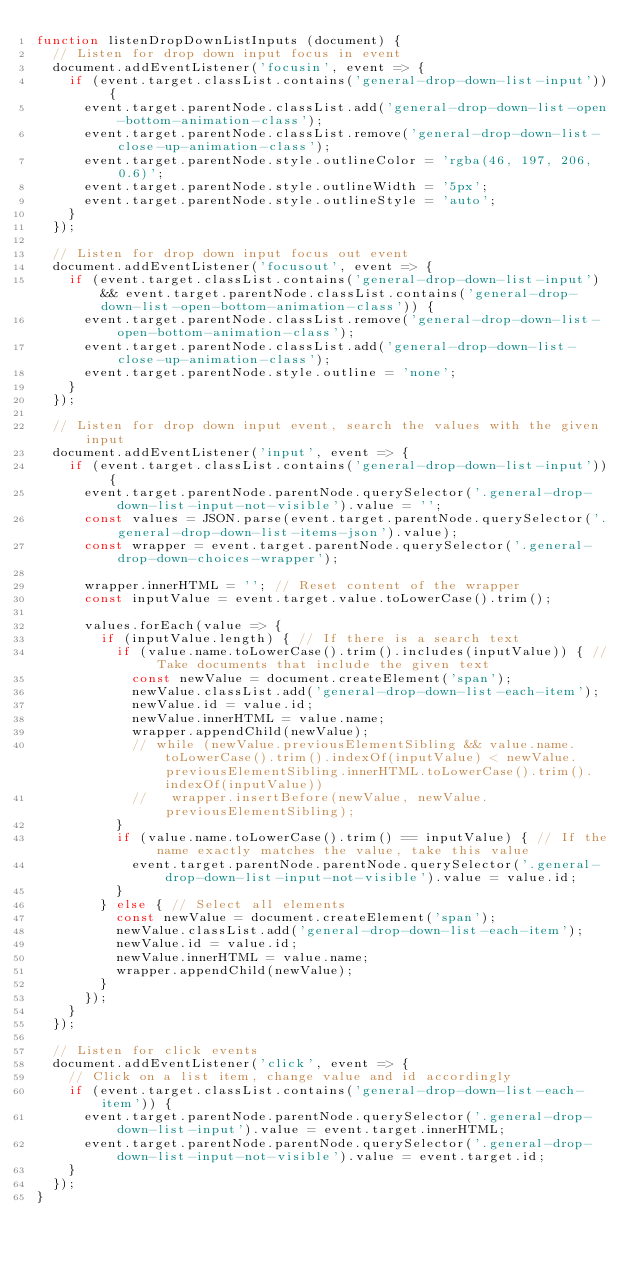Convert code to text. <code><loc_0><loc_0><loc_500><loc_500><_JavaScript_>function listenDropDownListInputs (document) {
  // Listen for drop down input focus in event
  document.addEventListener('focusin', event => {
    if (event.target.classList.contains('general-drop-down-list-input')) {
      event.target.parentNode.classList.add('general-drop-down-list-open-bottom-animation-class');
      event.target.parentNode.classList.remove('general-drop-down-list-close-up-animation-class');
      event.target.parentNode.style.outlineColor = 'rgba(46, 197, 206, 0.6)';
      event.target.parentNode.style.outlineWidth = '5px';
      event.target.parentNode.style.outlineStyle = 'auto';
    }
  });

  // Listen for drop down input focus out event
  document.addEventListener('focusout', event => {
    if (event.target.classList.contains('general-drop-down-list-input') && event.target.parentNode.classList.contains('general-drop-down-list-open-bottom-animation-class')) {
      event.target.parentNode.classList.remove('general-drop-down-list-open-bottom-animation-class');
      event.target.parentNode.classList.add('general-drop-down-list-close-up-animation-class');
      event.target.parentNode.style.outline = 'none';
    }
  });

  // Listen for drop down input event, search the values with the given input
  document.addEventListener('input', event => {
    if (event.target.classList.contains('general-drop-down-list-input')) {
      event.target.parentNode.parentNode.querySelector('.general-drop-down-list-input-not-visible').value = '';
      const values = JSON.parse(event.target.parentNode.querySelector('.general-drop-down-list-items-json').value);
      const wrapper = event.target.parentNode.querySelector('.general-drop-down-choices-wrapper');

      wrapper.innerHTML = ''; // Reset content of the wrapper
      const inputValue = event.target.value.toLowerCase().trim();

      values.forEach(value => {
        if (inputValue.length) { // If there is a search text
          if (value.name.toLowerCase().trim().includes(inputValue)) { // Take documents that include the given text
            const newValue = document.createElement('span');
            newValue.classList.add('general-drop-down-list-each-item');
            newValue.id = value.id;
            newValue.innerHTML = value.name;
            wrapper.appendChild(newValue);
            // while (newValue.previousElementSibling && value.name.toLowerCase().trim().indexOf(inputValue) < newValue.previousElementSibling.innerHTML.toLowerCase().trim().indexOf(inputValue))
            //   wrapper.insertBefore(newValue, newValue.previousElementSibling);
          }
          if (value.name.toLowerCase().trim() == inputValue) { // If the name exactly matches the value, take this value
            event.target.parentNode.parentNode.querySelector('.general-drop-down-list-input-not-visible').value = value.id;
          }
        } else { // Select all elements
          const newValue = document.createElement('span');
          newValue.classList.add('general-drop-down-list-each-item');
          newValue.id = value.id;
          newValue.innerHTML = value.name;
          wrapper.appendChild(newValue);
        }
      });
    }
  });

  // Listen for click events
  document.addEventListener('click', event => {
    // Click on a list item, change value and id accordingly
    if (event.target.classList.contains('general-drop-down-list-each-item')) {
      event.target.parentNode.parentNode.querySelector('.general-drop-down-list-input').value = event.target.innerHTML;
      event.target.parentNode.parentNode.querySelector('.general-drop-down-list-input-not-visible').value = event.target.id;
    }
  });
}
</code> 